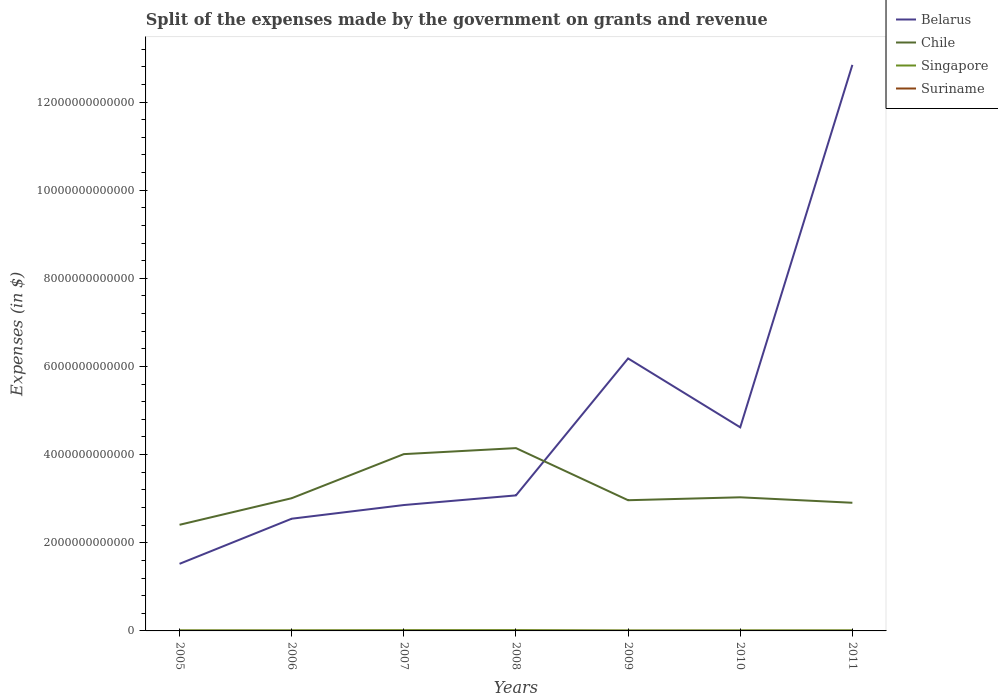Is the number of lines equal to the number of legend labels?
Your answer should be compact. Yes. Across all years, what is the maximum expenses made by the government on grants and revenue in Suriname?
Keep it short and to the point. 3.94e+08. What is the total expenses made by the government on grants and revenue in Chile in the graph?
Provide a succinct answer. 1.03e+11. What is the difference between the highest and the second highest expenses made by the government on grants and revenue in Belarus?
Offer a very short reply. 1.13e+13. What is the difference between the highest and the lowest expenses made by the government on grants and revenue in Belarus?
Make the answer very short. 2. Is the expenses made by the government on grants and revenue in Belarus strictly greater than the expenses made by the government on grants and revenue in Suriname over the years?
Make the answer very short. No. How many lines are there?
Make the answer very short. 4. How many years are there in the graph?
Offer a terse response. 7. What is the difference between two consecutive major ticks on the Y-axis?
Your response must be concise. 2.00e+12. Does the graph contain any zero values?
Make the answer very short. No. Where does the legend appear in the graph?
Your response must be concise. Top right. How are the legend labels stacked?
Keep it short and to the point. Vertical. What is the title of the graph?
Offer a terse response. Split of the expenses made by the government on grants and revenue. What is the label or title of the Y-axis?
Provide a short and direct response. Expenses (in $). What is the Expenses (in $) in Belarus in 2005?
Ensure brevity in your answer.  1.52e+12. What is the Expenses (in $) in Chile in 2005?
Keep it short and to the point. 2.41e+12. What is the Expenses (in $) of Singapore in 2005?
Ensure brevity in your answer.  1.40e+1. What is the Expenses (in $) in Suriname in 2005?
Give a very brief answer. 3.94e+08. What is the Expenses (in $) of Belarus in 2006?
Keep it short and to the point. 2.55e+12. What is the Expenses (in $) of Chile in 2006?
Offer a terse response. 3.01e+12. What is the Expenses (in $) of Singapore in 2006?
Offer a terse response. 1.43e+1. What is the Expenses (in $) in Suriname in 2006?
Provide a succinct answer. 5.33e+08. What is the Expenses (in $) in Belarus in 2007?
Make the answer very short. 2.86e+12. What is the Expenses (in $) of Chile in 2007?
Your response must be concise. 4.01e+12. What is the Expenses (in $) of Singapore in 2007?
Provide a succinct answer. 1.75e+1. What is the Expenses (in $) of Suriname in 2007?
Give a very brief answer. 8.47e+08. What is the Expenses (in $) of Belarus in 2008?
Make the answer very short. 3.08e+12. What is the Expenses (in $) in Chile in 2008?
Your response must be concise. 4.15e+12. What is the Expenses (in $) of Singapore in 2008?
Your response must be concise. 1.82e+1. What is the Expenses (in $) in Suriname in 2008?
Give a very brief answer. 6.72e+08. What is the Expenses (in $) of Belarus in 2009?
Offer a terse response. 6.18e+12. What is the Expenses (in $) in Chile in 2009?
Provide a short and direct response. 2.97e+12. What is the Expenses (in $) of Singapore in 2009?
Offer a terse response. 1.16e+1. What is the Expenses (in $) of Suriname in 2009?
Your answer should be compact. 1.11e+09. What is the Expenses (in $) in Belarus in 2010?
Your response must be concise. 4.62e+12. What is the Expenses (in $) in Chile in 2010?
Your answer should be compact. 3.03e+12. What is the Expenses (in $) in Singapore in 2010?
Give a very brief answer. 1.31e+1. What is the Expenses (in $) in Suriname in 2010?
Your response must be concise. 7.28e+08. What is the Expenses (in $) of Belarus in 2011?
Give a very brief answer. 1.28e+13. What is the Expenses (in $) of Chile in 2011?
Provide a succinct answer. 2.91e+12. What is the Expenses (in $) of Singapore in 2011?
Offer a terse response. 1.38e+1. What is the Expenses (in $) of Suriname in 2011?
Provide a short and direct response. 8.71e+08. Across all years, what is the maximum Expenses (in $) of Belarus?
Offer a very short reply. 1.28e+13. Across all years, what is the maximum Expenses (in $) in Chile?
Your answer should be compact. 4.15e+12. Across all years, what is the maximum Expenses (in $) in Singapore?
Your response must be concise. 1.82e+1. Across all years, what is the maximum Expenses (in $) in Suriname?
Offer a very short reply. 1.11e+09. Across all years, what is the minimum Expenses (in $) of Belarus?
Provide a succinct answer. 1.52e+12. Across all years, what is the minimum Expenses (in $) in Chile?
Your answer should be very brief. 2.41e+12. Across all years, what is the minimum Expenses (in $) of Singapore?
Provide a succinct answer. 1.16e+1. Across all years, what is the minimum Expenses (in $) of Suriname?
Offer a very short reply. 3.94e+08. What is the total Expenses (in $) of Belarus in the graph?
Your answer should be very brief. 3.36e+13. What is the total Expenses (in $) of Chile in the graph?
Your answer should be compact. 2.25e+13. What is the total Expenses (in $) of Singapore in the graph?
Offer a terse response. 1.03e+11. What is the total Expenses (in $) in Suriname in the graph?
Provide a short and direct response. 5.16e+09. What is the difference between the Expenses (in $) in Belarus in 2005 and that in 2006?
Offer a very short reply. -1.02e+12. What is the difference between the Expenses (in $) in Chile in 2005 and that in 2006?
Your response must be concise. -6.03e+11. What is the difference between the Expenses (in $) of Singapore in 2005 and that in 2006?
Give a very brief answer. -2.90e+08. What is the difference between the Expenses (in $) of Suriname in 2005 and that in 2006?
Offer a terse response. -1.39e+08. What is the difference between the Expenses (in $) of Belarus in 2005 and that in 2007?
Ensure brevity in your answer.  -1.33e+12. What is the difference between the Expenses (in $) in Chile in 2005 and that in 2007?
Keep it short and to the point. -1.60e+12. What is the difference between the Expenses (in $) in Singapore in 2005 and that in 2007?
Provide a short and direct response. -3.50e+09. What is the difference between the Expenses (in $) of Suriname in 2005 and that in 2007?
Give a very brief answer. -4.53e+08. What is the difference between the Expenses (in $) in Belarus in 2005 and that in 2008?
Your response must be concise. -1.55e+12. What is the difference between the Expenses (in $) in Chile in 2005 and that in 2008?
Your answer should be compact. -1.74e+12. What is the difference between the Expenses (in $) of Singapore in 2005 and that in 2008?
Make the answer very short. -4.21e+09. What is the difference between the Expenses (in $) of Suriname in 2005 and that in 2008?
Ensure brevity in your answer.  -2.78e+08. What is the difference between the Expenses (in $) of Belarus in 2005 and that in 2009?
Offer a very short reply. -4.66e+12. What is the difference between the Expenses (in $) in Chile in 2005 and that in 2009?
Provide a succinct answer. -5.58e+11. What is the difference between the Expenses (in $) of Singapore in 2005 and that in 2009?
Offer a very short reply. 2.46e+09. What is the difference between the Expenses (in $) in Suriname in 2005 and that in 2009?
Provide a succinct answer. -7.19e+08. What is the difference between the Expenses (in $) of Belarus in 2005 and that in 2010?
Keep it short and to the point. -3.10e+12. What is the difference between the Expenses (in $) in Chile in 2005 and that in 2010?
Provide a succinct answer. -6.24e+11. What is the difference between the Expenses (in $) in Singapore in 2005 and that in 2010?
Make the answer very short. 9.79e+08. What is the difference between the Expenses (in $) in Suriname in 2005 and that in 2010?
Make the answer very short. -3.34e+08. What is the difference between the Expenses (in $) of Belarus in 2005 and that in 2011?
Keep it short and to the point. -1.13e+13. What is the difference between the Expenses (in $) of Chile in 2005 and that in 2011?
Your answer should be compact. -5.00e+11. What is the difference between the Expenses (in $) of Singapore in 2005 and that in 2011?
Offer a terse response. 2.79e+08. What is the difference between the Expenses (in $) in Suriname in 2005 and that in 2011?
Provide a short and direct response. -4.76e+08. What is the difference between the Expenses (in $) of Belarus in 2006 and that in 2007?
Your response must be concise. -3.10e+11. What is the difference between the Expenses (in $) in Chile in 2006 and that in 2007?
Offer a very short reply. -1.00e+12. What is the difference between the Expenses (in $) of Singapore in 2006 and that in 2007?
Your answer should be very brief. -3.21e+09. What is the difference between the Expenses (in $) of Suriname in 2006 and that in 2007?
Provide a succinct answer. -3.14e+08. What is the difference between the Expenses (in $) of Belarus in 2006 and that in 2008?
Offer a terse response. -5.29e+11. What is the difference between the Expenses (in $) of Chile in 2006 and that in 2008?
Provide a succinct answer. -1.14e+12. What is the difference between the Expenses (in $) in Singapore in 2006 and that in 2008?
Your answer should be compact. -3.92e+09. What is the difference between the Expenses (in $) of Suriname in 2006 and that in 2008?
Offer a terse response. -1.39e+08. What is the difference between the Expenses (in $) in Belarus in 2006 and that in 2009?
Provide a succinct answer. -3.64e+12. What is the difference between the Expenses (in $) of Chile in 2006 and that in 2009?
Your answer should be very brief. 4.55e+1. What is the difference between the Expenses (in $) of Singapore in 2006 and that in 2009?
Keep it short and to the point. 2.75e+09. What is the difference between the Expenses (in $) of Suriname in 2006 and that in 2009?
Make the answer very short. -5.80e+08. What is the difference between the Expenses (in $) in Belarus in 2006 and that in 2010?
Provide a succinct answer. -2.07e+12. What is the difference between the Expenses (in $) in Chile in 2006 and that in 2010?
Provide a short and direct response. -2.07e+1. What is the difference between the Expenses (in $) of Singapore in 2006 and that in 2010?
Make the answer very short. 1.27e+09. What is the difference between the Expenses (in $) of Suriname in 2006 and that in 2010?
Ensure brevity in your answer.  -1.95e+08. What is the difference between the Expenses (in $) of Belarus in 2006 and that in 2011?
Keep it short and to the point. -1.03e+13. What is the difference between the Expenses (in $) in Chile in 2006 and that in 2011?
Offer a terse response. 1.03e+11. What is the difference between the Expenses (in $) in Singapore in 2006 and that in 2011?
Your response must be concise. 5.69e+08. What is the difference between the Expenses (in $) in Suriname in 2006 and that in 2011?
Your answer should be compact. -3.38e+08. What is the difference between the Expenses (in $) in Belarus in 2007 and that in 2008?
Give a very brief answer. -2.19e+11. What is the difference between the Expenses (in $) of Chile in 2007 and that in 2008?
Your response must be concise. -1.36e+11. What is the difference between the Expenses (in $) of Singapore in 2007 and that in 2008?
Provide a succinct answer. -7.12e+08. What is the difference between the Expenses (in $) of Suriname in 2007 and that in 2008?
Offer a very short reply. 1.75e+08. What is the difference between the Expenses (in $) of Belarus in 2007 and that in 2009?
Your answer should be compact. -3.33e+12. What is the difference between the Expenses (in $) in Chile in 2007 and that in 2009?
Your answer should be very brief. 1.05e+12. What is the difference between the Expenses (in $) of Singapore in 2007 and that in 2009?
Keep it short and to the point. 5.96e+09. What is the difference between the Expenses (in $) of Suriname in 2007 and that in 2009?
Offer a very short reply. -2.66e+08. What is the difference between the Expenses (in $) of Belarus in 2007 and that in 2010?
Ensure brevity in your answer.  -1.76e+12. What is the difference between the Expenses (in $) of Chile in 2007 and that in 2010?
Your answer should be very brief. 9.80e+11. What is the difference between the Expenses (in $) of Singapore in 2007 and that in 2010?
Your answer should be very brief. 4.48e+09. What is the difference between the Expenses (in $) in Suriname in 2007 and that in 2010?
Give a very brief answer. 1.19e+08. What is the difference between the Expenses (in $) of Belarus in 2007 and that in 2011?
Your answer should be compact. -9.99e+12. What is the difference between the Expenses (in $) of Chile in 2007 and that in 2011?
Make the answer very short. 1.10e+12. What is the difference between the Expenses (in $) of Singapore in 2007 and that in 2011?
Keep it short and to the point. 3.78e+09. What is the difference between the Expenses (in $) in Suriname in 2007 and that in 2011?
Your answer should be very brief. -2.36e+07. What is the difference between the Expenses (in $) of Belarus in 2008 and that in 2009?
Keep it short and to the point. -3.11e+12. What is the difference between the Expenses (in $) in Chile in 2008 and that in 2009?
Your answer should be compact. 1.18e+12. What is the difference between the Expenses (in $) in Singapore in 2008 and that in 2009?
Make the answer very short. 6.67e+09. What is the difference between the Expenses (in $) in Suriname in 2008 and that in 2009?
Provide a succinct answer. -4.41e+08. What is the difference between the Expenses (in $) in Belarus in 2008 and that in 2010?
Provide a succinct answer. -1.54e+12. What is the difference between the Expenses (in $) of Chile in 2008 and that in 2010?
Offer a very short reply. 1.12e+12. What is the difference between the Expenses (in $) of Singapore in 2008 and that in 2010?
Offer a very short reply. 5.19e+09. What is the difference between the Expenses (in $) in Suriname in 2008 and that in 2010?
Ensure brevity in your answer.  -5.62e+07. What is the difference between the Expenses (in $) of Belarus in 2008 and that in 2011?
Your answer should be compact. -9.77e+12. What is the difference between the Expenses (in $) in Chile in 2008 and that in 2011?
Give a very brief answer. 1.24e+12. What is the difference between the Expenses (in $) in Singapore in 2008 and that in 2011?
Keep it short and to the point. 4.49e+09. What is the difference between the Expenses (in $) in Suriname in 2008 and that in 2011?
Your answer should be compact. -1.99e+08. What is the difference between the Expenses (in $) of Belarus in 2009 and that in 2010?
Give a very brief answer. 1.56e+12. What is the difference between the Expenses (in $) of Chile in 2009 and that in 2010?
Offer a terse response. -6.61e+1. What is the difference between the Expenses (in $) in Singapore in 2009 and that in 2010?
Give a very brief answer. -1.48e+09. What is the difference between the Expenses (in $) in Suriname in 2009 and that in 2010?
Ensure brevity in your answer.  3.84e+08. What is the difference between the Expenses (in $) of Belarus in 2009 and that in 2011?
Your response must be concise. -6.66e+12. What is the difference between the Expenses (in $) in Chile in 2009 and that in 2011?
Provide a succinct answer. 5.78e+1. What is the difference between the Expenses (in $) of Singapore in 2009 and that in 2011?
Provide a succinct answer. -2.18e+09. What is the difference between the Expenses (in $) in Suriname in 2009 and that in 2011?
Keep it short and to the point. 2.42e+08. What is the difference between the Expenses (in $) of Belarus in 2010 and that in 2011?
Your response must be concise. -8.22e+12. What is the difference between the Expenses (in $) of Chile in 2010 and that in 2011?
Offer a very short reply. 1.24e+11. What is the difference between the Expenses (in $) of Singapore in 2010 and that in 2011?
Offer a very short reply. -7.00e+08. What is the difference between the Expenses (in $) in Suriname in 2010 and that in 2011?
Ensure brevity in your answer.  -1.42e+08. What is the difference between the Expenses (in $) of Belarus in 2005 and the Expenses (in $) of Chile in 2006?
Your answer should be compact. -1.49e+12. What is the difference between the Expenses (in $) of Belarus in 2005 and the Expenses (in $) of Singapore in 2006?
Give a very brief answer. 1.51e+12. What is the difference between the Expenses (in $) in Belarus in 2005 and the Expenses (in $) in Suriname in 2006?
Offer a terse response. 1.52e+12. What is the difference between the Expenses (in $) in Chile in 2005 and the Expenses (in $) in Singapore in 2006?
Your answer should be compact. 2.39e+12. What is the difference between the Expenses (in $) of Chile in 2005 and the Expenses (in $) of Suriname in 2006?
Ensure brevity in your answer.  2.41e+12. What is the difference between the Expenses (in $) of Singapore in 2005 and the Expenses (in $) of Suriname in 2006?
Make the answer very short. 1.35e+1. What is the difference between the Expenses (in $) of Belarus in 2005 and the Expenses (in $) of Chile in 2007?
Your answer should be compact. -2.49e+12. What is the difference between the Expenses (in $) in Belarus in 2005 and the Expenses (in $) in Singapore in 2007?
Offer a terse response. 1.50e+12. What is the difference between the Expenses (in $) in Belarus in 2005 and the Expenses (in $) in Suriname in 2007?
Give a very brief answer. 1.52e+12. What is the difference between the Expenses (in $) of Chile in 2005 and the Expenses (in $) of Singapore in 2007?
Give a very brief answer. 2.39e+12. What is the difference between the Expenses (in $) of Chile in 2005 and the Expenses (in $) of Suriname in 2007?
Provide a short and direct response. 2.41e+12. What is the difference between the Expenses (in $) of Singapore in 2005 and the Expenses (in $) of Suriname in 2007?
Ensure brevity in your answer.  1.32e+1. What is the difference between the Expenses (in $) in Belarus in 2005 and the Expenses (in $) in Chile in 2008?
Provide a succinct answer. -2.63e+12. What is the difference between the Expenses (in $) of Belarus in 2005 and the Expenses (in $) of Singapore in 2008?
Your answer should be very brief. 1.50e+12. What is the difference between the Expenses (in $) in Belarus in 2005 and the Expenses (in $) in Suriname in 2008?
Ensure brevity in your answer.  1.52e+12. What is the difference between the Expenses (in $) in Chile in 2005 and the Expenses (in $) in Singapore in 2008?
Offer a terse response. 2.39e+12. What is the difference between the Expenses (in $) in Chile in 2005 and the Expenses (in $) in Suriname in 2008?
Your response must be concise. 2.41e+12. What is the difference between the Expenses (in $) in Singapore in 2005 and the Expenses (in $) in Suriname in 2008?
Your answer should be compact. 1.34e+1. What is the difference between the Expenses (in $) of Belarus in 2005 and the Expenses (in $) of Chile in 2009?
Give a very brief answer. -1.44e+12. What is the difference between the Expenses (in $) in Belarus in 2005 and the Expenses (in $) in Singapore in 2009?
Your response must be concise. 1.51e+12. What is the difference between the Expenses (in $) of Belarus in 2005 and the Expenses (in $) of Suriname in 2009?
Provide a short and direct response. 1.52e+12. What is the difference between the Expenses (in $) in Chile in 2005 and the Expenses (in $) in Singapore in 2009?
Give a very brief answer. 2.40e+12. What is the difference between the Expenses (in $) of Chile in 2005 and the Expenses (in $) of Suriname in 2009?
Your response must be concise. 2.41e+12. What is the difference between the Expenses (in $) in Singapore in 2005 and the Expenses (in $) in Suriname in 2009?
Give a very brief answer. 1.29e+1. What is the difference between the Expenses (in $) in Belarus in 2005 and the Expenses (in $) in Chile in 2010?
Keep it short and to the point. -1.51e+12. What is the difference between the Expenses (in $) in Belarus in 2005 and the Expenses (in $) in Singapore in 2010?
Ensure brevity in your answer.  1.51e+12. What is the difference between the Expenses (in $) in Belarus in 2005 and the Expenses (in $) in Suriname in 2010?
Provide a short and direct response. 1.52e+12. What is the difference between the Expenses (in $) in Chile in 2005 and the Expenses (in $) in Singapore in 2010?
Your answer should be compact. 2.39e+12. What is the difference between the Expenses (in $) in Chile in 2005 and the Expenses (in $) in Suriname in 2010?
Your response must be concise. 2.41e+12. What is the difference between the Expenses (in $) in Singapore in 2005 and the Expenses (in $) in Suriname in 2010?
Offer a terse response. 1.33e+1. What is the difference between the Expenses (in $) of Belarus in 2005 and the Expenses (in $) of Chile in 2011?
Ensure brevity in your answer.  -1.39e+12. What is the difference between the Expenses (in $) of Belarus in 2005 and the Expenses (in $) of Singapore in 2011?
Give a very brief answer. 1.51e+12. What is the difference between the Expenses (in $) in Belarus in 2005 and the Expenses (in $) in Suriname in 2011?
Keep it short and to the point. 1.52e+12. What is the difference between the Expenses (in $) of Chile in 2005 and the Expenses (in $) of Singapore in 2011?
Offer a very short reply. 2.39e+12. What is the difference between the Expenses (in $) in Chile in 2005 and the Expenses (in $) in Suriname in 2011?
Your answer should be compact. 2.41e+12. What is the difference between the Expenses (in $) in Singapore in 2005 and the Expenses (in $) in Suriname in 2011?
Ensure brevity in your answer.  1.32e+1. What is the difference between the Expenses (in $) in Belarus in 2006 and the Expenses (in $) in Chile in 2007?
Your response must be concise. -1.47e+12. What is the difference between the Expenses (in $) in Belarus in 2006 and the Expenses (in $) in Singapore in 2007?
Provide a short and direct response. 2.53e+12. What is the difference between the Expenses (in $) in Belarus in 2006 and the Expenses (in $) in Suriname in 2007?
Ensure brevity in your answer.  2.55e+12. What is the difference between the Expenses (in $) in Chile in 2006 and the Expenses (in $) in Singapore in 2007?
Make the answer very short. 2.99e+12. What is the difference between the Expenses (in $) of Chile in 2006 and the Expenses (in $) of Suriname in 2007?
Keep it short and to the point. 3.01e+12. What is the difference between the Expenses (in $) of Singapore in 2006 and the Expenses (in $) of Suriname in 2007?
Give a very brief answer. 1.35e+1. What is the difference between the Expenses (in $) of Belarus in 2006 and the Expenses (in $) of Chile in 2008?
Keep it short and to the point. -1.60e+12. What is the difference between the Expenses (in $) of Belarus in 2006 and the Expenses (in $) of Singapore in 2008?
Provide a succinct answer. 2.53e+12. What is the difference between the Expenses (in $) of Belarus in 2006 and the Expenses (in $) of Suriname in 2008?
Give a very brief answer. 2.55e+12. What is the difference between the Expenses (in $) in Chile in 2006 and the Expenses (in $) in Singapore in 2008?
Keep it short and to the point. 2.99e+12. What is the difference between the Expenses (in $) in Chile in 2006 and the Expenses (in $) in Suriname in 2008?
Ensure brevity in your answer.  3.01e+12. What is the difference between the Expenses (in $) in Singapore in 2006 and the Expenses (in $) in Suriname in 2008?
Give a very brief answer. 1.37e+1. What is the difference between the Expenses (in $) of Belarus in 2006 and the Expenses (in $) of Chile in 2009?
Offer a terse response. -4.20e+11. What is the difference between the Expenses (in $) in Belarus in 2006 and the Expenses (in $) in Singapore in 2009?
Your answer should be compact. 2.53e+12. What is the difference between the Expenses (in $) in Belarus in 2006 and the Expenses (in $) in Suriname in 2009?
Provide a short and direct response. 2.54e+12. What is the difference between the Expenses (in $) in Chile in 2006 and the Expenses (in $) in Singapore in 2009?
Offer a very short reply. 3.00e+12. What is the difference between the Expenses (in $) in Chile in 2006 and the Expenses (in $) in Suriname in 2009?
Provide a succinct answer. 3.01e+12. What is the difference between the Expenses (in $) in Singapore in 2006 and the Expenses (in $) in Suriname in 2009?
Give a very brief answer. 1.32e+1. What is the difference between the Expenses (in $) of Belarus in 2006 and the Expenses (in $) of Chile in 2010?
Your answer should be compact. -4.86e+11. What is the difference between the Expenses (in $) of Belarus in 2006 and the Expenses (in $) of Singapore in 2010?
Provide a short and direct response. 2.53e+12. What is the difference between the Expenses (in $) of Belarus in 2006 and the Expenses (in $) of Suriname in 2010?
Your answer should be very brief. 2.55e+12. What is the difference between the Expenses (in $) of Chile in 2006 and the Expenses (in $) of Singapore in 2010?
Provide a short and direct response. 3.00e+12. What is the difference between the Expenses (in $) in Chile in 2006 and the Expenses (in $) in Suriname in 2010?
Provide a short and direct response. 3.01e+12. What is the difference between the Expenses (in $) of Singapore in 2006 and the Expenses (in $) of Suriname in 2010?
Give a very brief answer. 1.36e+1. What is the difference between the Expenses (in $) of Belarus in 2006 and the Expenses (in $) of Chile in 2011?
Make the answer very short. -3.62e+11. What is the difference between the Expenses (in $) of Belarus in 2006 and the Expenses (in $) of Singapore in 2011?
Your response must be concise. 2.53e+12. What is the difference between the Expenses (in $) in Belarus in 2006 and the Expenses (in $) in Suriname in 2011?
Provide a succinct answer. 2.55e+12. What is the difference between the Expenses (in $) in Chile in 2006 and the Expenses (in $) in Singapore in 2011?
Your answer should be compact. 3.00e+12. What is the difference between the Expenses (in $) in Chile in 2006 and the Expenses (in $) in Suriname in 2011?
Your answer should be compact. 3.01e+12. What is the difference between the Expenses (in $) in Singapore in 2006 and the Expenses (in $) in Suriname in 2011?
Your answer should be very brief. 1.35e+1. What is the difference between the Expenses (in $) in Belarus in 2007 and the Expenses (in $) in Chile in 2008?
Your answer should be very brief. -1.29e+12. What is the difference between the Expenses (in $) of Belarus in 2007 and the Expenses (in $) of Singapore in 2008?
Keep it short and to the point. 2.84e+12. What is the difference between the Expenses (in $) of Belarus in 2007 and the Expenses (in $) of Suriname in 2008?
Provide a short and direct response. 2.86e+12. What is the difference between the Expenses (in $) of Chile in 2007 and the Expenses (in $) of Singapore in 2008?
Your answer should be very brief. 3.99e+12. What is the difference between the Expenses (in $) of Chile in 2007 and the Expenses (in $) of Suriname in 2008?
Keep it short and to the point. 4.01e+12. What is the difference between the Expenses (in $) in Singapore in 2007 and the Expenses (in $) in Suriname in 2008?
Provide a succinct answer. 1.69e+1. What is the difference between the Expenses (in $) of Belarus in 2007 and the Expenses (in $) of Chile in 2009?
Make the answer very short. -1.09e+11. What is the difference between the Expenses (in $) in Belarus in 2007 and the Expenses (in $) in Singapore in 2009?
Give a very brief answer. 2.84e+12. What is the difference between the Expenses (in $) of Belarus in 2007 and the Expenses (in $) of Suriname in 2009?
Offer a terse response. 2.86e+12. What is the difference between the Expenses (in $) of Chile in 2007 and the Expenses (in $) of Singapore in 2009?
Your response must be concise. 4.00e+12. What is the difference between the Expenses (in $) of Chile in 2007 and the Expenses (in $) of Suriname in 2009?
Make the answer very short. 4.01e+12. What is the difference between the Expenses (in $) of Singapore in 2007 and the Expenses (in $) of Suriname in 2009?
Give a very brief answer. 1.64e+1. What is the difference between the Expenses (in $) in Belarus in 2007 and the Expenses (in $) in Chile in 2010?
Your answer should be very brief. -1.75e+11. What is the difference between the Expenses (in $) of Belarus in 2007 and the Expenses (in $) of Singapore in 2010?
Make the answer very short. 2.84e+12. What is the difference between the Expenses (in $) of Belarus in 2007 and the Expenses (in $) of Suriname in 2010?
Make the answer very short. 2.86e+12. What is the difference between the Expenses (in $) of Chile in 2007 and the Expenses (in $) of Singapore in 2010?
Make the answer very short. 4.00e+12. What is the difference between the Expenses (in $) of Chile in 2007 and the Expenses (in $) of Suriname in 2010?
Give a very brief answer. 4.01e+12. What is the difference between the Expenses (in $) in Singapore in 2007 and the Expenses (in $) in Suriname in 2010?
Offer a terse response. 1.68e+1. What is the difference between the Expenses (in $) of Belarus in 2007 and the Expenses (in $) of Chile in 2011?
Offer a very short reply. -5.15e+1. What is the difference between the Expenses (in $) in Belarus in 2007 and the Expenses (in $) in Singapore in 2011?
Your response must be concise. 2.84e+12. What is the difference between the Expenses (in $) in Belarus in 2007 and the Expenses (in $) in Suriname in 2011?
Give a very brief answer. 2.86e+12. What is the difference between the Expenses (in $) of Chile in 2007 and the Expenses (in $) of Singapore in 2011?
Provide a short and direct response. 4.00e+12. What is the difference between the Expenses (in $) in Chile in 2007 and the Expenses (in $) in Suriname in 2011?
Your answer should be very brief. 4.01e+12. What is the difference between the Expenses (in $) in Singapore in 2007 and the Expenses (in $) in Suriname in 2011?
Keep it short and to the point. 1.67e+1. What is the difference between the Expenses (in $) of Belarus in 2008 and the Expenses (in $) of Chile in 2009?
Your response must be concise. 1.10e+11. What is the difference between the Expenses (in $) in Belarus in 2008 and the Expenses (in $) in Singapore in 2009?
Make the answer very short. 3.06e+12. What is the difference between the Expenses (in $) in Belarus in 2008 and the Expenses (in $) in Suriname in 2009?
Keep it short and to the point. 3.07e+12. What is the difference between the Expenses (in $) in Chile in 2008 and the Expenses (in $) in Singapore in 2009?
Offer a terse response. 4.14e+12. What is the difference between the Expenses (in $) in Chile in 2008 and the Expenses (in $) in Suriname in 2009?
Offer a terse response. 4.15e+12. What is the difference between the Expenses (in $) in Singapore in 2008 and the Expenses (in $) in Suriname in 2009?
Your response must be concise. 1.71e+1. What is the difference between the Expenses (in $) of Belarus in 2008 and the Expenses (in $) of Chile in 2010?
Provide a short and direct response. 4.34e+1. What is the difference between the Expenses (in $) of Belarus in 2008 and the Expenses (in $) of Singapore in 2010?
Make the answer very short. 3.06e+12. What is the difference between the Expenses (in $) in Belarus in 2008 and the Expenses (in $) in Suriname in 2010?
Give a very brief answer. 3.07e+12. What is the difference between the Expenses (in $) of Chile in 2008 and the Expenses (in $) of Singapore in 2010?
Give a very brief answer. 4.13e+12. What is the difference between the Expenses (in $) in Chile in 2008 and the Expenses (in $) in Suriname in 2010?
Your response must be concise. 4.15e+12. What is the difference between the Expenses (in $) in Singapore in 2008 and the Expenses (in $) in Suriname in 2010?
Offer a very short reply. 1.75e+1. What is the difference between the Expenses (in $) of Belarus in 2008 and the Expenses (in $) of Chile in 2011?
Offer a terse response. 1.67e+11. What is the difference between the Expenses (in $) in Belarus in 2008 and the Expenses (in $) in Singapore in 2011?
Your response must be concise. 3.06e+12. What is the difference between the Expenses (in $) in Belarus in 2008 and the Expenses (in $) in Suriname in 2011?
Make the answer very short. 3.07e+12. What is the difference between the Expenses (in $) in Chile in 2008 and the Expenses (in $) in Singapore in 2011?
Give a very brief answer. 4.13e+12. What is the difference between the Expenses (in $) in Chile in 2008 and the Expenses (in $) in Suriname in 2011?
Make the answer very short. 4.15e+12. What is the difference between the Expenses (in $) in Singapore in 2008 and the Expenses (in $) in Suriname in 2011?
Your answer should be compact. 1.74e+1. What is the difference between the Expenses (in $) of Belarus in 2009 and the Expenses (in $) of Chile in 2010?
Provide a succinct answer. 3.15e+12. What is the difference between the Expenses (in $) in Belarus in 2009 and the Expenses (in $) in Singapore in 2010?
Keep it short and to the point. 6.17e+12. What is the difference between the Expenses (in $) of Belarus in 2009 and the Expenses (in $) of Suriname in 2010?
Provide a succinct answer. 6.18e+12. What is the difference between the Expenses (in $) of Chile in 2009 and the Expenses (in $) of Singapore in 2010?
Your answer should be very brief. 2.95e+12. What is the difference between the Expenses (in $) in Chile in 2009 and the Expenses (in $) in Suriname in 2010?
Keep it short and to the point. 2.96e+12. What is the difference between the Expenses (in $) in Singapore in 2009 and the Expenses (in $) in Suriname in 2010?
Provide a short and direct response. 1.08e+1. What is the difference between the Expenses (in $) of Belarus in 2009 and the Expenses (in $) of Chile in 2011?
Offer a very short reply. 3.27e+12. What is the difference between the Expenses (in $) in Belarus in 2009 and the Expenses (in $) in Singapore in 2011?
Give a very brief answer. 6.17e+12. What is the difference between the Expenses (in $) of Belarus in 2009 and the Expenses (in $) of Suriname in 2011?
Offer a terse response. 6.18e+12. What is the difference between the Expenses (in $) of Chile in 2009 and the Expenses (in $) of Singapore in 2011?
Offer a terse response. 2.95e+12. What is the difference between the Expenses (in $) of Chile in 2009 and the Expenses (in $) of Suriname in 2011?
Your response must be concise. 2.96e+12. What is the difference between the Expenses (in $) of Singapore in 2009 and the Expenses (in $) of Suriname in 2011?
Provide a succinct answer. 1.07e+1. What is the difference between the Expenses (in $) of Belarus in 2010 and the Expenses (in $) of Chile in 2011?
Your answer should be very brief. 1.71e+12. What is the difference between the Expenses (in $) of Belarus in 2010 and the Expenses (in $) of Singapore in 2011?
Keep it short and to the point. 4.61e+12. What is the difference between the Expenses (in $) in Belarus in 2010 and the Expenses (in $) in Suriname in 2011?
Provide a short and direct response. 4.62e+12. What is the difference between the Expenses (in $) in Chile in 2010 and the Expenses (in $) in Singapore in 2011?
Your answer should be very brief. 3.02e+12. What is the difference between the Expenses (in $) in Chile in 2010 and the Expenses (in $) in Suriname in 2011?
Provide a succinct answer. 3.03e+12. What is the difference between the Expenses (in $) of Singapore in 2010 and the Expenses (in $) of Suriname in 2011?
Your response must be concise. 1.22e+1. What is the average Expenses (in $) in Belarus per year?
Offer a very short reply. 4.81e+12. What is the average Expenses (in $) of Chile per year?
Give a very brief answer. 3.21e+12. What is the average Expenses (in $) of Singapore per year?
Offer a very short reply. 1.46e+1. What is the average Expenses (in $) of Suriname per year?
Give a very brief answer. 7.37e+08. In the year 2005, what is the difference between the Expenses (in $) in Belarus and Expenses (in $) in Chile?
Provide a short and direct response. -8.86e+11. In the year 2005, what is the difference between the Expenses (in $) in Belarus and Expenses (in $) in Singapore?
Keep it short and to the point. 1.51e+12. In the year 2005, what is the difference between the Expenses (in $) in Belarus and Expenses (in $) in Suriname?
Your answer should be very brief. 1.52e+12. In the year 2005, what is the difference between the Expenses (in $) in Chile and Expenses (in $) in Singapore?
Your response must be concise. 2.39e+12. In the year 2005, what is the difference between the Expenses (in $) in Chile and Expenses (in $) in Suriname?
Ensure brevity in your answer.  2.41e+12. In the year 2005, what is the difference between the Expenses (in $) of Singapore and Expenses (in $) of Suriname?
Provide a short and direct response. 1.36e+1. In the year 2006, what is the difference between the Expenses (in $) in Belarus and Expenses (in $) in Chile?
Provide a short and direct response. -4.65e+11. In the year 2006, what is the difference between the Expenses (in $) in Belarus and Expenses (in $) in Singapore?
Your response must be concise. 2.53e+12. In the year 2006, what is the difference between the Expenses (in $) in Belarus and Expenses (in $) in Suriname?
Your response must be concise. 2.55e+12. In the year 2006, what is the difference between the Expenses (in $) in Chile and Expenses (in $) in Singapore?
Ensure brevity in your answer.  3.00e+12. In the year 2006, what is the difference between the Expenses (in $) in Chile and Expenses (in $) in Suriname?
Offer a terse response. 3.01e+12. In the year 2006, what is the difference between the Expenses (in $) in Singapore and Expenses (in $) in Suriname?
Provide a succinct answer. 1.38e+1. In the year 2007, what is the difference between the Expenses (in $) of Belarus and Expenses (in $) of Chile?
Make the answer very short. -1.16e+12. In the year 2007, what is the difference between the Expenses (in $) of Belarus and Expenses (in $) of Singapore?
Your answer should be very brief. 2.84e+12. In the year 2007, what is the difference between the Expenses (in $) of Belarus and Expenses (in $) of Suriname?
Your response must be concise. 2.86e+12. In the year 2007, what is the difference between the Expenses (in $) in Chile and Expenses (in $) in Singapore?
Make the answer very short. 3.99e+12. In the year 2007, what is the difference between the Expenses (in $) in Chile and Expenses (in $) in Suriname?
Offer a terse response. 4.01e+12. In the year 2007, what is the difference between the Expenses (in $) in Singapore and Expenses (in $) in Suriname?
Provide a short and direct response. 1.67e+1. In the year 2008, what is the difference between the Expenses (in $) in Belarus and Expenses (in $) in Chile?
Your answer should be compact. -1.07e+12. In the year 2008, what is the difference between the Expenses (in $) of Belarus and Expenses (in $) of Singapore?
Your response must be concise. 3.06e+12. In the year 2008, what is the difference between the Expenses (in $) of Belarus and Expenses (in $) of Suriname?
Provide a succinct answer. 3.07e+12. In the year 2008, what is the difference between the Expenses (in $) of Chile and Expenses (in $) of Singapore?
Your response must be concise. 4.13e+12. In the year 2008, what is the difference between the Expenses (in $) in Chile and Expenses (in $) in Suriname?
Give a very brief answer. 4.15e+12. In the year 2008, what is the difference between the Expenses (in $) of Singapore and Expenses (in $) of Suriname?
Provide a short and direct response. 1.76e+1. In the year 2009, what is the difference between the Expenses (in $) in Belarus and Expenses (in $) in Chile?
Your response must be concise. 3.22e+12. In the year 2009, what is the difference between the Expenses (in $) in Belarus and Expenses (in $) in Singapore?
Give a very brief answer. 6.17e+12. In the year 2009, what is the difference between the Expenses (in $) in Belarus and Expenses (in $) in Suriname?
Your response must be concise. 6.18e+12. In the year 2009, what is the difference between the Expenses (in $) of Chile and Expenses (in $) of Singapore?
Your answer should be compact. 2.95e+12. In the year 2009, what is the difference between the Expenses (in $) in Chile and Expenses (in $) in Suriname?
Your answer should be compact. 2.96e+12. In the year 2009, what is the difference between the Expenses (in $) of Singapore and Expenses (in $) of Suriname?
Offer a very short reply. 1.05e+1. In the year 2010, what is the difference between the Expenses (in $) in Belarus and Expenses (in $) in Chile?
Provide a succinct answer. 1.59e+12. In the year 2010, what is the difference between the Expenses (in $) of Belarus and Expenses (in $) of Singapore?
Offer a very short reply. 4.61e+12. In the year 2010, what is the difference between the Expenses (in $) of Belarus and Expenses (in $) of Suriname?
Give a very brief answer. 4.62e+12. In the year 2010, what is the difference between the Expenses (in $) of Chile and Expenses (in $) of Singapore?
Provide a succinct answer. 3.02e+12. In the year 2010, what is the difference between the Expenses (in $) of Chile and Expenses (in $) of Suriname?
Offer a terse response. 3.03e+12. In the year 2010, what is the difference between the Expenses (in $) of Singapore and Expenses (in $) of Suriname?
Provide a succinct answer. 1.23e+1. In the year 2011, what is the difference between the Expenses (in $) of Belarus and Expenses (in $) of Chile?
Keep it short and to the point. 9.94e+12. In the year 2011, what is the difference between the Expenses (in $) of Belarus and Expenses (in $) of Singapore?
Your response must be concise. 1.28e+13. In the year 2011, what is the difference between the Expenses (in $) in Belarus and Expenses (in $) in Suriname?
Give a very brief answer. 1.28e+13. In the year 2011, what is the difference between the Expenses (in $) in Chile and Expenses (in $) in Singapore?
Your response must be concise. 2.89e+12. In the year 2011, what is the difference between the Expenses (in $) of Chile and Expenses (in $) of Suriname?
Offer a terse response. 2.91e+12. In the year 2011, what is the difference between the Expenses (in $) in Singapore and Expenses (in $) in Suriname?
Provide a succinct answer. 1.29e+1. What is the ratio of the Expenses (in $) of Belarus in 2005 to that in 2006?
Provide a succinct answer. 0.6. What is the ratio of the Expenses (in $) in Chile in 2005 to that in 2006?
Offer a terse response. 0.8. What is the ratio of the Expenses (in $) in Singapore in 2005 to that in 2006?
Ensure brevity in your answer.  0.98. What is the ratio of the Expenses (in $) in Suriname in 2005 to that in 2006?
Your answer should be very brief. 0.74. What is the ratio of the Expenses (in $) of Belarus in 2005 to that in 2007?
Your answer should be very brief. 0.53. What is the ratio of the Expenses (in $) of Chile in 2005 to that in 2007?
Make the answer very short. 0.6. What is the ratio of the Expenses (in $) in Singapore in 2005 to that in 2007?
Your response must be concise. 0.8. What is the ratio of the Expenses (in $) in Suriname in 2005 to that in 2007?
Your response must be concise. 0.47. What is the ratio of the Expenses (in $) of Belarus in 2005 to that in 2008?
Offer a terse response. 0.5. What is the ratio of the Expenses (in $) of Chile in 2005 to that in 2008?
Make the answer very short. 0.58. What is the ratio of the Expenses (in $) in Singapore in 2005 to that in 2008?
Your response must be concise. 0.77. What is the ratio of the Expenses (in $) in Suriname in 2005 to that in 2008?
Keep it short and to the point. 0.59. What is the ratio of the Expenses (in $) of Belarus in 2005 to that in 2009?
Ensure brevity in your answer.  0.25. What is the ratio of the Expenses (in $) of Chile in 2005 to that in 2009?
Make the answer very short. 0.81. What is the ratio of the Expenses (in $) in Singapore in 2005 to that in 2009?
Your answer should be compact. 1.21. What is the ratio of the Expenses (in $) in Suriname in 2005 to that in 2009?
Make the answer very short. 0.35. What is the ratio of the Expenses (in $) of Belarus in 2005 to that in 2010?
Give a very brief answer. 0.33. What is the ratio of the Expenses (in $) of Chile in 2005 to that in 2010?
Offer a terse response. 0.79. What is the ratio of the Expenses (in $) of Singapore in 2005 to that in 2010?
Provide a succinct answer. 1.07. What is the ratio of the Expenses (in $) in Suriname in 2005 to that in 2010?
Give a very brief answer. 0.54. What is the ratio of the Expenses (in $) in Belarus in 2005 to that in 2011?
Offer a very short reply. 0.12. What is the ratio of the Expenses (in $) in Chile in 2005 to that in 2011?
Give a very brief answer. 0.83. What is the ratio of the Expenses (in $) in Singapore in 2005 to that in 2011?
Offer a very short reply. 1.02. What is the ratio of the Expenses (in $) in Suriname in 2005 to that in 2011?
Provide a short and direct response. 0.45. What is the ratio of the Expenses (in $) in Belarus in 2006 to that in 2007?
Make the answer very short. 0.89. What is the ratio of the Expenses (in $) of Chile in 2006 to that in 2007?
Offer a very short reply. 0.75. What is the ratio of the Expenses (in $) of Singapore in 2006 to that in 2007?
Offer a terse response. 0.82. What is the ratio of the Expenses (in $) of Suriname in 2006 to that in 2007?
Your answer should be very brief. 0.63. What is the ratio of the Expenses (in $) in Belarus in 2006 to that in 2008?
Give a very brief answer. 0.83. What is the ratio of the Expenses (in $) of Chile in 2006 to that in 2008?
Offer a very short reply. 0.73. What is the ratio of the Expenses (in $) in Singapore in 2006 to that in 2008?
Provide a short and direct response. 0.79. What is the ratio of the Expenses (in $) in Suriname in 2006 to that in 2008?
Your answer should be very brief. 0.79. What is the ratio of the Expenses (in $) in Belarus in 2006 to that in 2009?
Your response must be concise. 0.41. What is the ratio of the Expenses (in $) in Chile in 2006 to that in 2009?
Keep it short and to the point. 1.02. What is the ratio of the Expenses (in $) in Singapore in 2006 to that in 2009?
Your answer should be compact. 1.24. What is the ratio of the Expenses (in $) of Suriname in 2006 to that in 2009?
Ensure brevity in your answer.  0.48. What is the ratio of the Expenses (in $) of Belarus in 2006 to that in 2010?
Keep it short and to the point. 0.55. What is the ratio of the Expenses (in $) in Singapore in 2006 to that in 2010?
Ensure brevity in your answer.  1.1. What is the ratio of the Expenses (in $) of Suriname in 2006 to that in 2010?
Ensure brevity in your answer.  0.73. What is the ratio of the Expenses (in $) in Belarus in 2006 to that in 2011?
Offer a terse response. 0.2. What is the ratio of the Expenses (in $) in Chile in 2006 to that in 2011?
Offer a terse response. 1.04. What is the ratio of the Expenses (in $) of Singapore in 2006 to that in 2011?
Your answer should be compact. 1.04. What is the ratio of the Expenses (in $) of Suriname in 2006 to that in 2011?
Your answer should be compact. 0.61. What is the ratio of the Expenses (in $) of Belarus in 2007 to that in 2008?
Your answer should be very brief. 0.93. What is the ratio of the Expenses (in $) of Chile in 2007 to that in 2008?
Offer a terse response. 0.97. What is the ratio of the Expenses (in $) in Singapore in 2007 to that in 2008?
Make the answer very short. 0.96. What is the ratio of the Expenses (in $) in Suriname in 2007 to that in 2008?
Your answer should be compact. 1.26. What is the ratio of the Expenses (in $) in Belarus in 2007 to that in 2009?
Offer a terse response. 0.46. What is the ratio of the Expenses (in $) in Chile in 2007 to that in 2009?
Give a very brief answer. 1.35. What is the ratio of the Expenses (in $) in Singapore in 2007 to that in 2009?
Provide a short and direct response. 1.51. What is the ratio of the Expenses (in $) of Suriname in 2007 to that in 2009?
Offer a terse response. 0.76. What is the ratio of the Expenses (in $) of Belarus in 2007 to that in 2010?
Your answer should be compact. 0.62. What is the ratio of the Expenses (in $) in Chile in 2007 to that in 2010?
Give a very brief answer. 1.32. What is the ratio of the Expenses (in $) in Singapore in 2007 to that in 2010?
Give a very brief answer. 1.34. What is the ratio of the Expenses (in $) in Suriname in 2007 to that in 2010?
Your response must be concise. 1.16. What is the ratio of the Expenses (in $) of Belarus in 2007 to that in 2011?
Ensure brevity in your answer.  0.22. What is the ratio of the Expenses (in $) in Chile in 2007 to that in 2011?
Offer a terse response. 1.38. What is the ratio of the Expenses (in $) in Singapore in 2007 to that in 2011?
Your answer should be compact. 1.27. What is the ratio of the Expenses (in $) in Suriname in 2007 to that in 2011?
Your answer should be very brief. 0.97. What is the ratio of the Expenses (in $) of Belarus in 2008 to that in 2009?
Make the answer very short. 0.5. What is the ratio of the Expenses (in $) of Chile in 2008 to that in 2009?
Offer a terse response. 1.4. What is the ratio of the Expenses (in $) in Singapore in 2008 to that in 2009?
Your response must be concise. 1.58. What is the ratio of the Expenses (in $) of Suriname in 2008 to that in 2009?
Your response must be concise. 0.6. What is the ratio of the Expenses (in $) of Belarus in 2008 to that in 2010?
Ensure brevity in your answer.  0.67. What is the ratio of the Expenses (in $) in Chile in 2008 to that in 2010?
Your response must be concise. 1.37. What is the ratio of the Expenses (in $) in Singapore in 2008 to that in 2010?
Make the answer very short. 1.4. What is the ratio of the Expenses (in $) in Suriname in 2008 to that in 2010?
Your answer should be very brief. 0.92. What is the ratio of the Expenses (in $) of Belarus in 2008 to that in 2011?
Ensure brevity in your answer.  0.24. What is the ratio of the Expenses (in $) in Chile in 2008 to that in 2011?
Your answer should be very brief. 1.43. What is the ratio of the Expenses (in $) of Singapore in 2008 to that in 2011?
Your answer should be very brief. 1.33. What is the ratio of the Expenses (in $) in Suriname in 2008 to that in 2011?
Make the answer very short. 0.77. What is the ratio of the Expenses (in $) in Belarus in 2009 to that in 2010?
Your response must be concise. 1.34. What is the ratio of the Expenses (in $) of Chile in 2009 to that in 2010?
Offer a very short reply. 0.98. What is the ratio of the Expenses (in $) in Singapore in 2009 to that in 2010?
Make the answer very short. 0.89. What is the ratio of the Expenses (in $) of Suriname in 2009 to that in 2010?
Your response must be concise. 1.53. What is the ratio of the Expenses (in $) in Belarus in 2009 to that in 2011?
Your answer should be very brief. 0.48. What is the ratio of the Expenses (in $) of Chile in 2009 to that in 2011?
Make the answer very short. 1.02. What is the ratio of the Expenses (in $) of Singapore in 2009 to that in 2011?
Your answer should be compact. 0.84. What is the ratio of the Expenses (in $) of Suriname in 2009 to that in 2011?
Give a very brief answer. 1.28. What is the ratio of the Expenses (in $) of Belarus in 2010 to that in 2011?
Ensure brevity in your answer.  0.36. What is the ratio of the Expenses (in $) in Chile in 2010 to that in 2011?
Keep it short and to the point. 1.04. What is the ratio of the Expenses (in $) in Singapore in 2010 to that in 2011?
Give a very brief answer. 0.95. What is the ratio of the Expenses (in $) of Suriname in 2010 to that in 2011?
Your answer should be very brief. 0.84. What is the difference between the highest and the second highest Expenses (in $) of Belarus?
Ensure brevity in your answer.  6.66e+12. What is the difference between the highest and the second highest Expenses (in $) in Chile?
Provide a short and direct response. 1.36e+11. What is the difference between the highest and the second highest Expenses (in $) of Singapore?
Provide a succinct answer. 7.12e+08. What is the difference between the highest and the second highest Expenses (in $) in Suriname?
Offer a very short reply. 2.42e+08. What is the difference between the highest and the lowest Expenses (in $) in Belarus?
Your response must be concise. 1.13e+13. What is the difference between the highest and the lowest Expenses (in $) of Chile?
Give a very brief answer. 1.74e+12. What is the difference between the highest and the lowest Expenses (in $) of Singapore?
Offer a very short reply. 6.67e+09. What is the difference between the highest and the lowest Expenses (in $) in Suriname?
Offer a very short reply. 7.19e+08. 